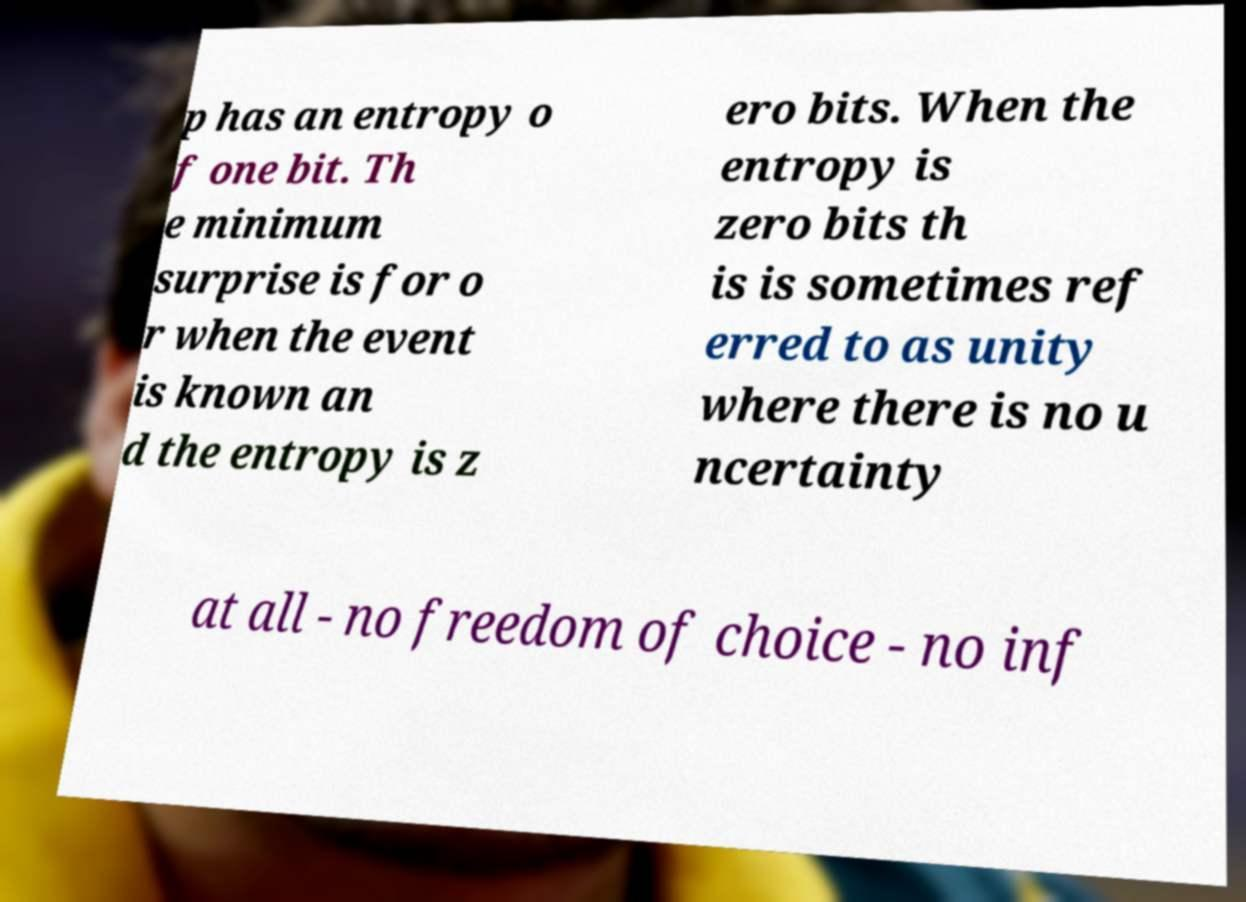Could you assist in decoding the text presented in this image and type it out clearly? p has an entropy o f one bit. Th e minimum surprise is for o r when the event is known an d the entropy is z ero bits. When the entropy is zero bits th is is sometimes ref erred to as unity where there is no u ncertainty at all - no freedom of choice - no inf 